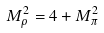Convert formula to latex. <formula><loc_0><loc_0><loc_500><loc_500>M _ { \rho } ^ { 2 } = 4 + M _ { \pi } ^ { 2 }</formula> 